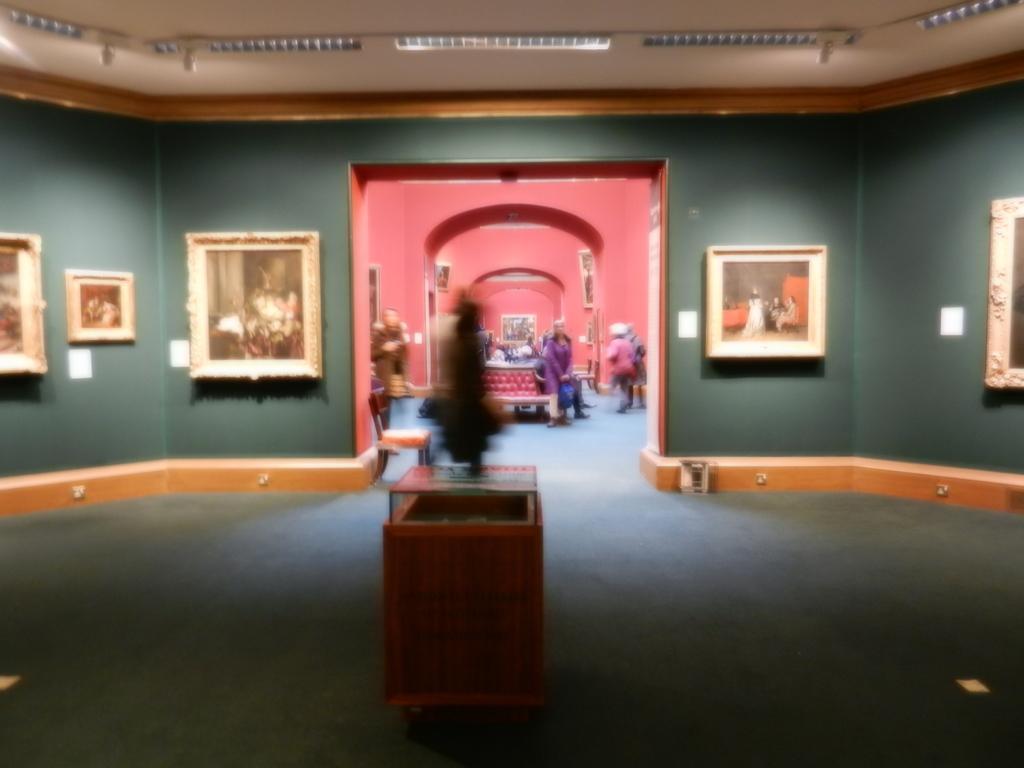In one or two sentences, can you explain what this image depicts? This image is taken indoors. At the bottom of the image there is a floor. In the background there are a few walls with many picture frames on it. In the middle of the image there is a sculpture and a few people are standing on the floor and a few are sitting on the bench. At the top of the image there is a roof with lights. 